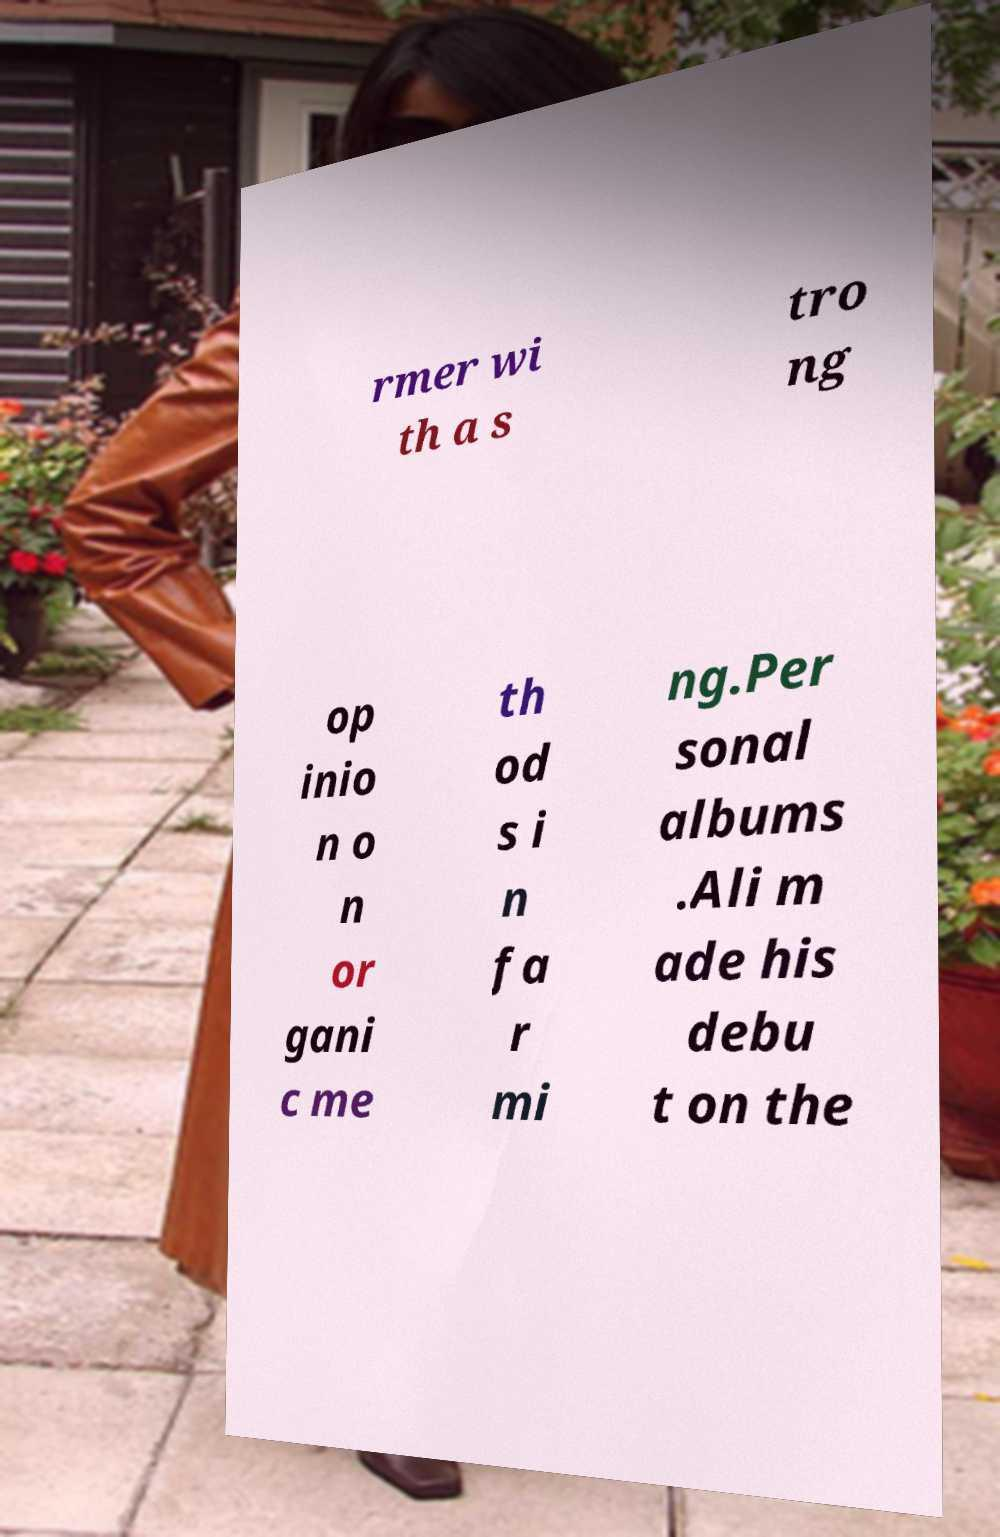What messages or text are displayed in this image? I need them in a readable, typed format. rmer wi th a s tro ng op inio n o n or gani c me th od s i n fa r mi ng.Per sonal albums .Ali m ade his debu t on the 